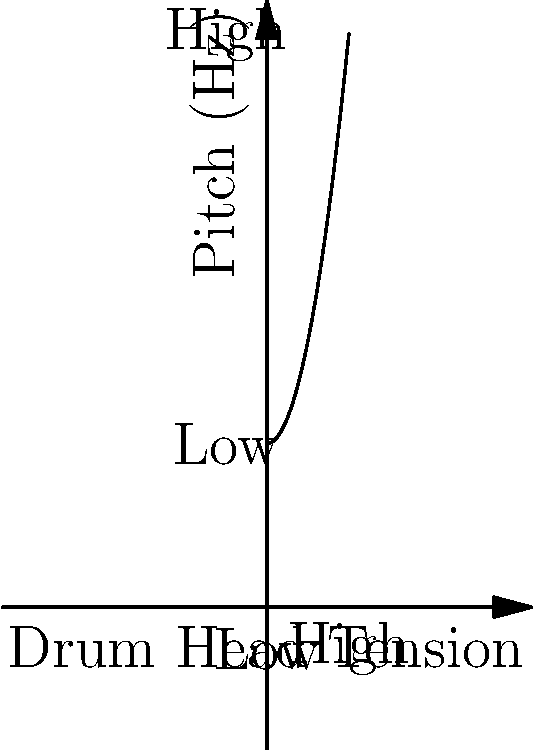As a traveling drum set player, you often need to adjust your drum heads for different venues and musical styles. The graph shows the relationship between drum head tension and pitch. How does increasing the tension of a drum head affect its pitch? To answer this question, let's analyze the graph step-by-step:

1. The x-axis represents drum head tension, ranging from low to high.
2. The y-axis represents pitch, measured in Hertz (Hz), also ranging from low to high.
3. The curve on the graph shows a positive correlation between tension and pitch.
4. As we move from left to right (increasing tension):
   a. The curve rises steadily.
   b. The slope of the curve increases, indicating an accelerating rate of change.
5. This relationship can be described mathematically as roughly quadratic ($$y \propto x^2$$).

In musical terms, this means:
- As you tighten the drum head, the pitch increases.
- The increase in pitch becomes more pronounced at higher tensions.
- This relationship is consistent with the physics of vibrating membranes, where frequency (pitch) is proportional to the square root of tension.

For a bohemian drummer performing in various festivals, understanding this relationship is crucial for achieving the desired sound in different acoustic environments and musical genres.
Answer: Increasing drum head tension raises the pitch non-linearly, with more pronounced increases at higher tensions. 